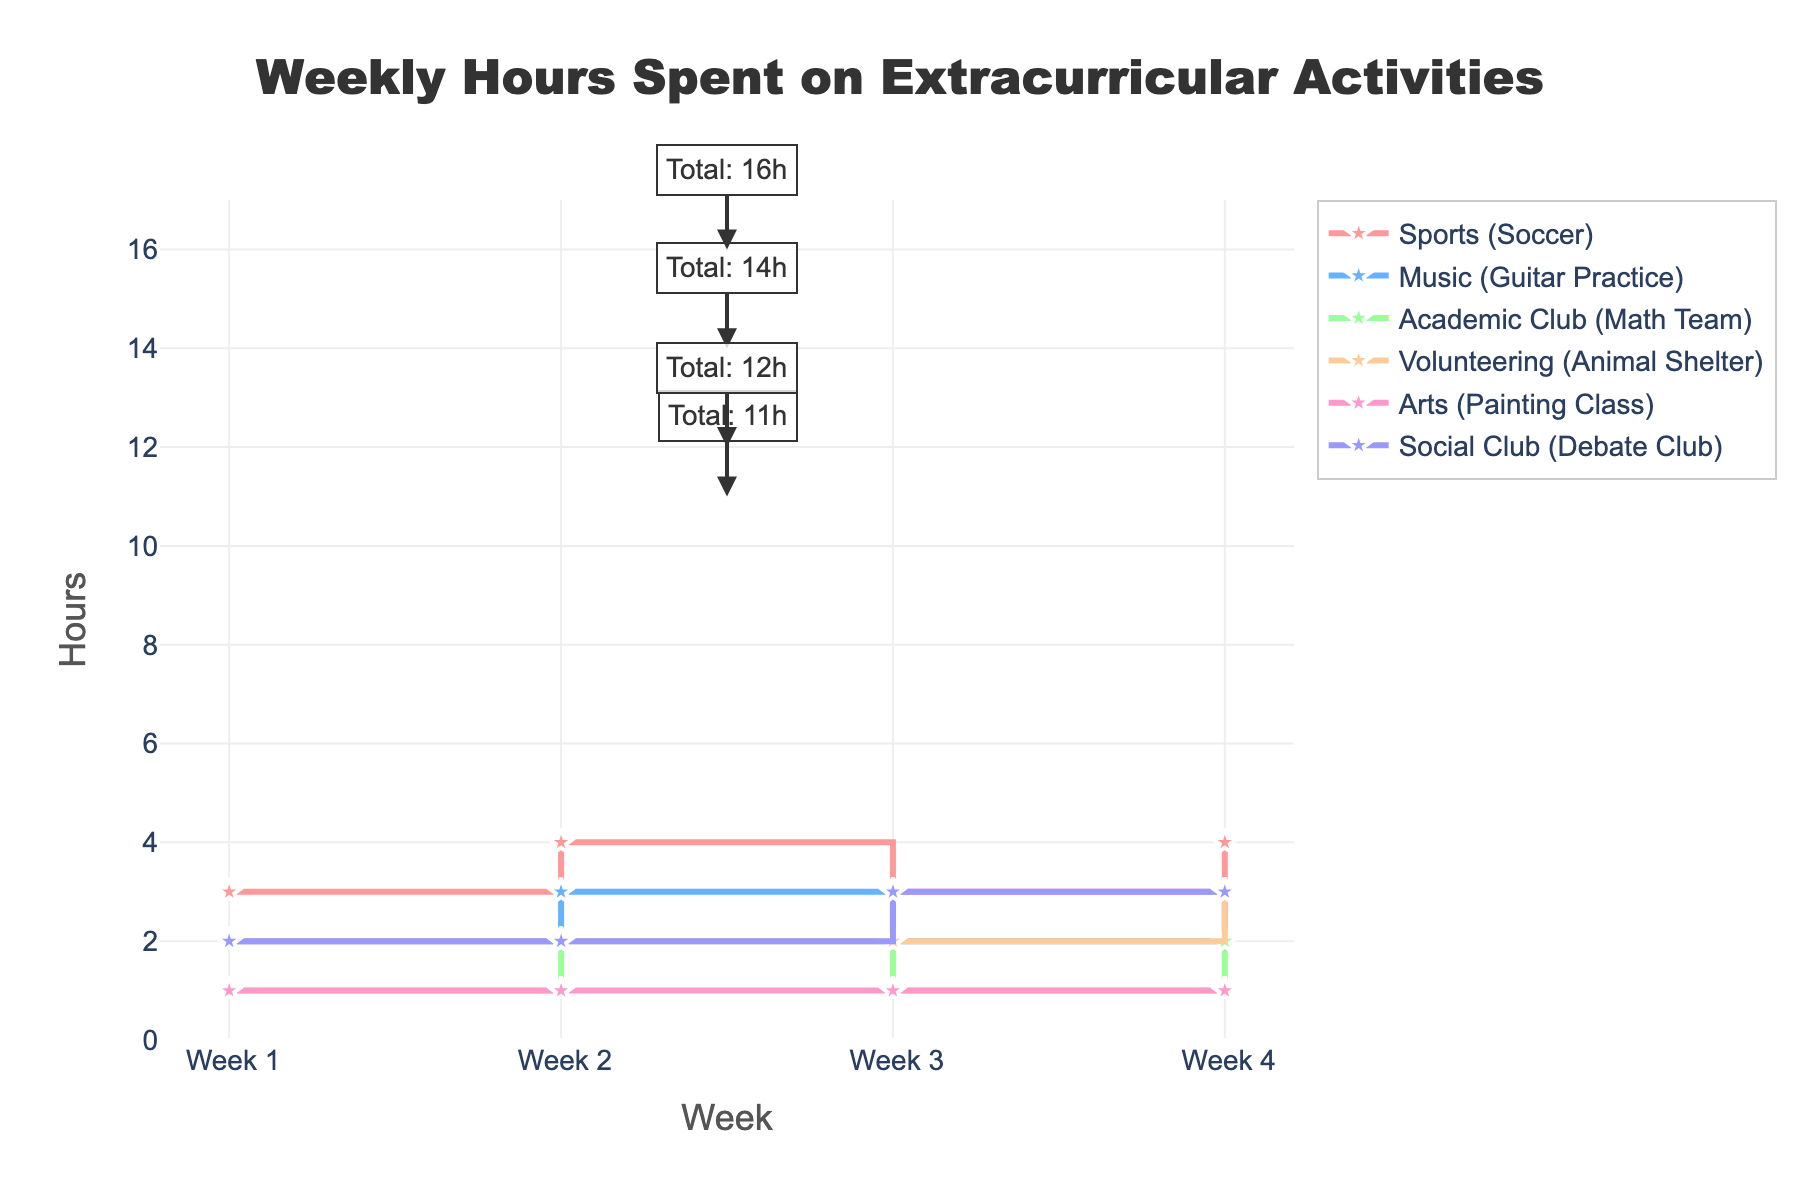What's the title of the figure? Look at the top of the plot where the largest text is located. It clearly states the title of the figure.
Answer: Weekly Hours Spent on Extracurricular Activities How many weeks are represented in the figure? Check the x-axis of the plot which is labeled as "Week". Count the distinct labels that appear along this axis.
Answer: 4 Which activity has the most consistent number of hours per week? Observing the y-values associated with each activity line, identify which line has the least variation across different weeks.
Answer: Arts (Painting Class) In which week did the total hours spent on activities peak? Annotated total hours for each week are visible on the plot. Identify the highest annotation value and track which week it corresponds to.
Answer: Week 4 Which extracurricular activity sees the highest increase in hours from Week 1 to Week 4? Note the y-values of all activities at Week 1 and Week 4, calculate the differences, and identify the highest increase.
Answer: Social Club (Debate Club) What is the sum of hours spent on 'Music (Guitar Practice)' and 'Volunteering (Animal Shelter)' in Week 2? Locate the hours for both activities in Week 2 from the plot and sum them up.
Answer: 5 How many activities have the same amount of hours in Week 3 as in Week 1? Compare the y-values of Week 3 and Week 1 for all activities to see how many have not changed.
Answer: 3 Did any activities have the same number of hours in all four weeks? Check the y-values of each activity across all weeks and see if there are any lines that remain constant.
Answer: Yes, Arts (Painting Class) Which activity shows an alternating pattern in the hours spent, and how does this pattern appear? Look for a line that fluctuates up and down consistently from week to week. This pattern indicates an alternation.
Answer: Sports (Soccer): 3, 4, 3, 4 How many total hours were spent on all activities combined in Week 3? Directly refer to the annotation on Week 3 that indicates total hours spent.
Answer: 12 